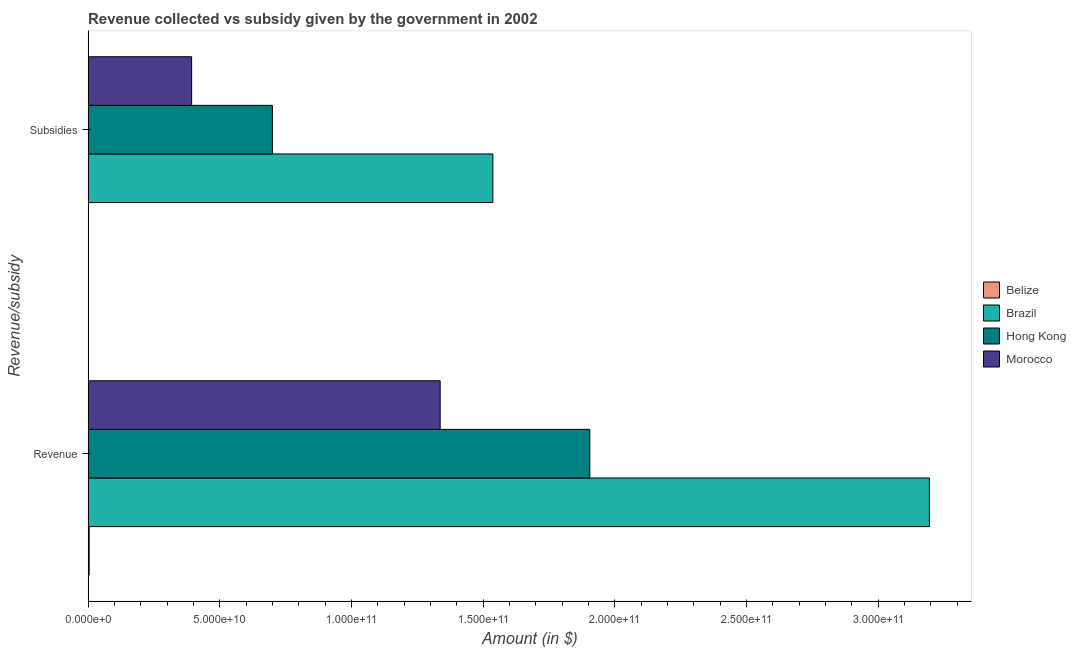How many different coloured bars are there?
Keep it short and to the point. 4. How many groups of bars are there?
Make the answer very short. 2. How many bars are there on the 1st tick from the top?
Keep it short and to the point. 4. How many bars are there on the 1st tick from the bottom?
Your response must be concise. 4. What is the label of the 2nd group of bars from the top?
Your response must be concise. Revenue. What is the amount of revenue collected in Brazil?
Keep it short and to the point. 3.19e+11. Across all countries, what is the maximum amount of subsidies given?
Ensure brevity in your answer.  1.54e+11. Across all countries, what is the minimum amount of revenue collected?
Your response must be concise. 4.12e+08. In which country was the amount of subsidies given minimum?
Make the answer very short. Belize. What is the total amount of revenue collected in the graph?
Provide a short and direct response. 6.44e+11. What is the difference between the amount of subsidies given in Brazil and that in Belize?
Offer a terse response. 1.54e+11. What is the difference between the amount of subsidies given in Belize and the amount of revenue collected in Morocco?
Your response must be concise. -1.34e+11. What is the average amount of revenue collected per country?
Give a very brief answer. 1.61e+11. What is the difference between the amount of subsidies given and amount of revenue collected in Morocco?
Give a very brief answer. -9.44e+1. In how many countries, is the amount of revenue collected greater than 200000000000 $?
Provide a succinct answer. 1. What is the ratio of the amount of subsidies given in Morocco to that in Hong Kong?
Give a very brief answer. 0.56. Is the amount of revenue collected in Brazil less than that in Belize?
Your answer should be compact. No. In how many countries, is the amount of revenue collected greater than the average amount of revenue collected taken over all countries?
Ensure brevity in your answer.  2. What does the 2nd bar from the top in Subsidies represents?
Provide a short and direct response. Hong Kong. What does the 3rd bar from the bottom in Subsidies represents?
Make the answer very short. Hong Kong. Are all the bars in the graph horizontal?
Ensure brevity in your answer.  Yes. What is the difference between two consecutive major ticks on the X-axis?
Provide a short and direct response. 5.00e+1. Are the values on the major ticks of X-axis written in scientific E-notation?
Your answer should be very brief. Yes. Does the graph contain any zero values?
Offer a very short reply. No. Does the graph contain grids?
Provide a succinct answer. No. How many legend labels are there?
Provide a succinct answer. 4. What is the title of the graph?
Your answer should be compact. Revenue collected vs subsidy given by the government in 2002. Does "Swaziland" appear as one of the legend labels in the graph?
Offer a terse response. No. What is the label or title of the X-axis?
Your answer should be very brief. Amount (in $). What is the label or title of the Y-axis?
Your answer should be very brief. Revenue/subsidy. What is the Amount (in $) of Belize in Revenue?
Make the answer very short. 4.12e+08. What is the Amount (in $) in Brazil in Revenue?
Your answer should be compact. 3.19e+11. What is the Amount (in $) of Hong Kong in Revenue?
Provide a succinct answer. 1.91e+11. What is the Amount (in $) of Morocco in Revenue?
Your response must be concise. 1.34e+11. What is the Amount (in $) in Belize in Subsidies?
Your answer should be compact. 5.21e+07. What is the Amount (in $) of Brazil in Subsidies?
Offer a very short reply. 1.54e+11. What is the Amount (in $) in Hong Kong in Subsidies?
Give a very brief answer. 7.00e+1. What is the Amount (in $) of Morocco in Subsidies?
Keep it short and to the point. 3.93e+1. Across all Revenue/subsidy, what is the maximum Amount (in $) in Belize?
Make the answer very short. 4.12e+08. Across all Revenue/subsidy, what is the maximum Amount (in $) in Brazil?
Your answer should be compact. 3.19e+11. Across all Revenue/subsidy, what is the maximum Amount (in $) of Hong Kong?
Your answer should be compact. 1.91e+11. Across all Revenue/subsidy, what is the maximum Amount (in $) of Morocco?
Offer a very short reply. 1.34e+11. Across all Revenue/subsidy, what is the minimum Amount (in $) of Belize?
Offer a terse response. 5.21e+07. Across all Revenue/subsidy, what is the minimum Amount (in $) in Brazil?
Provide a short and direct response. 1.54e+11. Across all Revenue/subsidy, what is the minimum Amount (in $) of Hong Kong?
Your answer should be compact. 7.00e+1. Across all Revenue/subsidy, what is the minimum Amount (in $) in Morocco?
Your response must be concise. 3.93e+1. What is the total Amount (in $) in Belize in the graph?
Give a very brief answer. 4.64e+08. What is the total Amount (in $) of Brazil in the graph?
Keep it short and to the point. 4.73e+11. What is the total Amount (in $) of Hong Kong in the graph?
Offer a very short reply. 2.61e+11. What is the total Amount (in $) of Morocco in the graph?
Provide a succinct answer. 1.73e+11. What is the difference between the Amount (in $) of Belize in Revenue and that in Subsidies?
Your response must be concise. 3.60e+08. What is the difference between the Amount (in $) in Brazil in Revenue and that in Subsidies?
Make the answer very short. 1.66e+11. What is the difference between the Amount (in $) of Hong Kong in Revenue and that in Subsidies?
Keep it short and to the point. 1.21e+11. What is the difference between the Amount (in $) in Morocco in Revenue and that in Subsidies?
Your response must be concise. 9.44e+1. What is the difference between the Amount (in $) in Belize in Revenue and the Amount (in $) in Brazil in Subsidies?
Provide a short and direct response. -1.53e+11. What is the difference between the Amount (in $) of Belize in Revenue and the Amount (in $) of Hong Kong in Subsidies?
Your answer should be very brief. -6.96e+1. What is the difference between the Amount (in $) of Belize in Revenue and the Amount (in $) of Morocco in Subsidies?
Give a very brief answer. -3.89e+1. What is the difference between the Amount (in $) of Brazil in Revenue and the Amount (in $) of Hong Kong in Subsidies?
Offer a very short reply. 2.50e+11. What is the difference between the Amount (in $) in Brazil in Revenue and the Amount (in $) in Morocco in Subsidies?
Your response must be concise. 2.80e+11. What is the difference between the Amount (in $) of Hong Kong in Revenue and the Amount (in $) of Morocco in Subsidies?
Offer a terse response. 1.51e+11. What is the average Amount (in $) in Belize per Revenue/subsidy?
Your answer should be compact. 2.32e+08. What is the average Amount (in $) of Brazil per Revenue/subsidy?
Your response must be concise. 2.37e+11. What is the average Amount (in $) in Hong Kong per Revenue/subsidy?
Give a very brief answer. 1.30e+11. What is the average Amount (in $) of Morocco per Revenue/subsidy?
Offer a very short reply. 8.65e+1. What is the difference between the Amount (in $) in Belize and Amount (in $) in Brazil in Revenue?
Keep it short and to the point. -3.19e+11. What is the difference between the Amount (in $) in Belize and Amount (in $) in Hong Kong in Revenue?
Offer a terse response. -1.90e+11. What is the difference between the Amount (in $) in Belize and Amount (in $) in Morocco in Revenue?
Your answer should be compact. -1.33e+11. What is the difference between the Amount (in $) in Brazil and Amount (in $) in Hong Kong in Revenue?
Keep it short and to the point. 1.29e+11. What is the difference between the Amount (in $) of Brazil and Amount (in $) of Morocco in Revenue?
Ensure brevity in your answer.  1.86e+11. What is the difference between the Amount (in $) of Hong Kong and Amount (in $) of Morocco in Revenue?
Make the answer very short. 5.68e+1. What is the difference between the Amount (in $) in Belize and Amount (in $) in Brazil in Subsidies?
Offer a very short reply. -1.54e+11. What is the difference between the Amount (in $) of Belize and Amount (in $) of Hong Kong in Subsidies?
Your response must be concise. -6.99e+1. What is the difference between the Amount (in $) in Belize and Amount (in $) in Morocco in Subsidies?
Offer a very short reply. -3.93e+1. What is the difference between the Amount (in $) in Brazil and Amount (in $) in Hong Kong in Subsidies?
Offer a very short reply. 8.37e+1. What is the difference between the Amount (in $) of Brazil and Amount (in $) of Morocco in Subsidies?
Your response must be concise. 1.14e+11. What is the difference between the Amount (in $) of Hong Kong and Amount (in $) of Morocco in Subsidies?
Offer a very short reply. 3.07e+1. What is the ratio of the Amount (in $) of Belize in Revenue to that in Subsidies?
Your answer should be very brief. 7.9. What is the ratio of the Amount (in $) in Brazil in Revenue to that in Subsidies?
Provide a succinct answer. 2.08. What is the ratio of the Amount (in $) in Hong Kong in Revenue to that in Subsidies?
Ensure brevity in your answer.  2.72. What is the ratio of the Amount (in $) of Morocco in Revenue to that in Subsidies?
Keep it short and to the point. 3.4. What is the difference between the highest and the second highest Amount (in $) in Belize?
Provide a succinct answer. 3.60e+08. What is the difference between the highest and the second highest Amount (in $) of Brazil?
Make the answer very short. 1.66e+11. What is the difference between the highest and the second highest Amount (in $) of Hong Kong?
Keep it short and to the point. 1.21e+11. What is the difference between the highest and the second highest Amount (in $) in Morocco?
Your response must be concise. 9.44e+1. What is the difference between the highest and the lowest Amount (in $) in Belize?
Offer a very short reply. 3.60e+08. What is the difference between the highest and the lowest Amount (in $) in Brazil?
Your answer should be compact. 1.66e+11. What is the difference between the highest and the lowest Amount (in $) in Hong Kong?
Keep it short and to the point. 1.21e+11. What is the difference between the highest and the lowest Amount (in $) of Morocco?
Offer a terse response. 9.44e+1. 